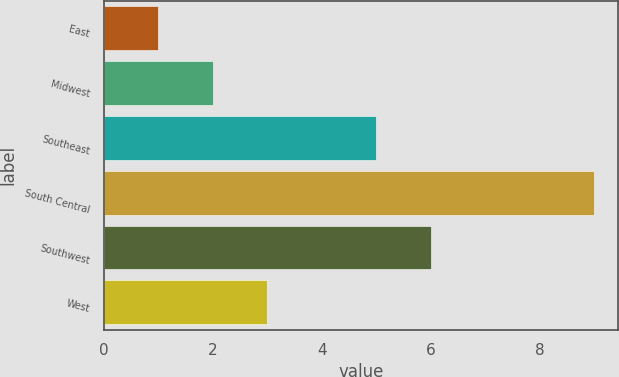<chart> <loc_0><loc_0><loc_500><loc_500><bar_chart><fcel>East<fcel>Midwest<fcel>Southeast<fcel>South Central<fcel>Southwest<fcel>West<nl><fcel>1<fcel>2<fcel>5<fcel>9<fcel>6<fcel>3<nl></chart> 